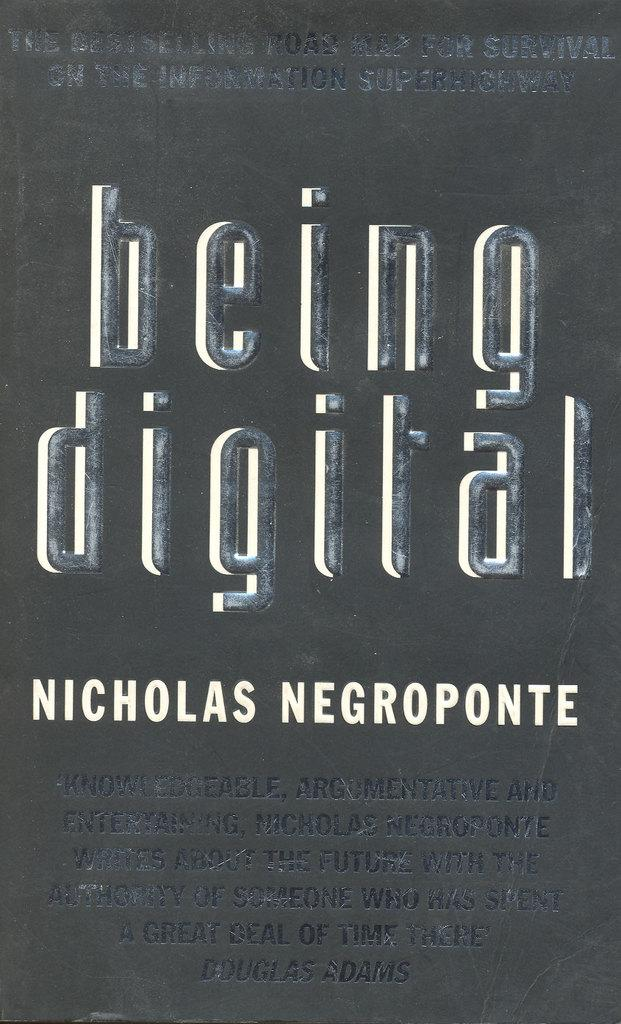Provide a one-sentence caption for the provided image. The book being digital is a best selling book. 